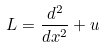<formula> <loc_0><loc_0><loc_500><loc_500>L = \frac { d ^ { 2 } } { d x ^ { 2 } } + u</formula> 